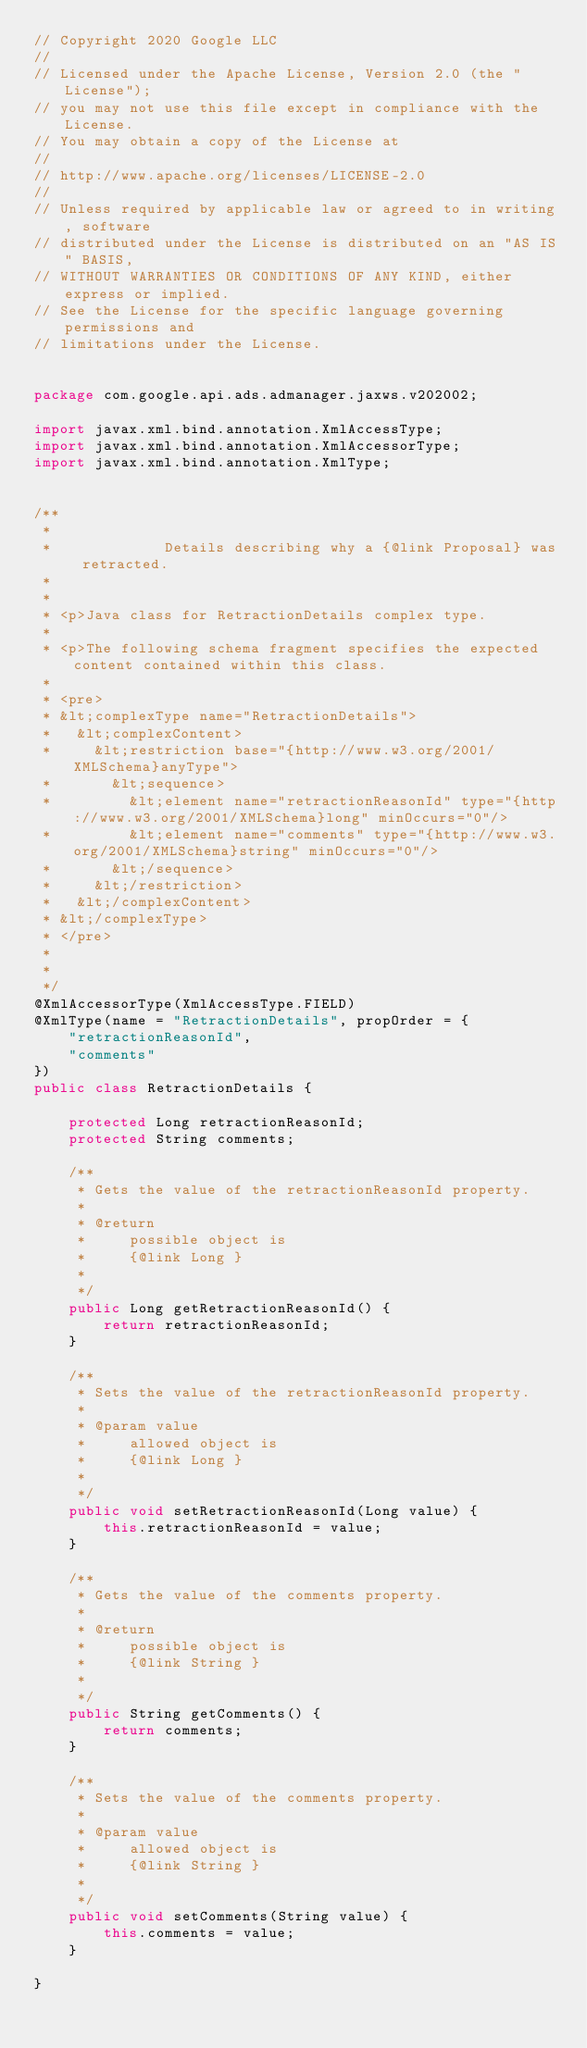<code> <loc_0><loc_0><loc_500><loc_500><_Java_>// Copyright 2020 Google LLC
//
// Licensed under the Apache License, Version 2.0 (the "License");
// you may not use this file except in compliance with the License.
// You may obtain a copy of the License at
//
// http://www.apache.org/licenses/LICENSE-2.0
//
// Unless required by applicable law or agreed to in writing, software
// distributed under the License is distributed on an "AS IS" BASIS,
// WITHOUT WARRANTIES OR CONDITIONS OF ANY KIND, either express or implied.
// See the License for the specific language governing permissions and
// limitations under the License.


package com.google.api.ads.admanager.jaxws.v202002;

import javax.xml.bind.annotation.XmlAccessType;
import javax.xml.bind.annotation.XmlAccessorType;
import javax.xml.bind.annotation.XmlType;


/**
 * 
 *             Details describing why a {@link Proposal} was retracted.
 *           
 * 
 * <p>Java class for RetractionDetails complex type.
 * 
 * <p>The following schema fragment specifies the expected content contained within this class.
 * 
 * <pre>
 * &lt;complexType name="RetractionDetails">
 *   &lt;complexContent>
 *     &lt;restriction base="{http://www.w3.org/2001/XMLSchema}anyType">
 *       &lt;sequence>
 *         &lt;element name="retractionReasonId" type="{http://www.w3.org/2001/XMLSchema}long" minOccurs="0"/>
 *         &lt;element name="comments" type="{http://www.w3.org/2001/XMLSchema}string" minOccurs="0"/>
 *       &lt;/sequence>
 *     &lt;/restriction>
 *   &lt;/complexContent>
 * &lt;/complexType>
 * </pre>
 * 
 * 
 */
@XmlAccessorType(XmlAccessType.FIELD)
@XmlType(name = "RetractionDetails", propOrder = {
    "retractionReasonId",
    "comments"
})
public class RetractionDetails {

    protected Long retractionReasonId;
    protected String comments;

    /**
     * Gets the value of the retractionReasonId property.
     * 
     * @return
     *     possible object is
     *     {@link Long }
     *     
     */
    public Long getRetractionReasonId() {
        return retractionReasonId;
    }

    /**
     * Sets the value of the retractionReasonId property.
     * 
     * @param value
     *     allowed object is
     *     {@link Long }
     *     
     */
    public void setRetractionReasonId(Long value) {
        this.retractionReasonId = value;
    }

    /**
     * Gets the value of the comments property.
     * 
     * @return
     *     possible object is
     *     {@link String }
     *     
     */
    public String getComments() {
        return comments;
    }

    /**
     * Sets the value of the comments property.
     * 
     * @param value
     *     allowed object is
     *     {@link String }
     *     
     */
    public void setComments(String value) {
        this.comments = value;
    }

}
</code> 